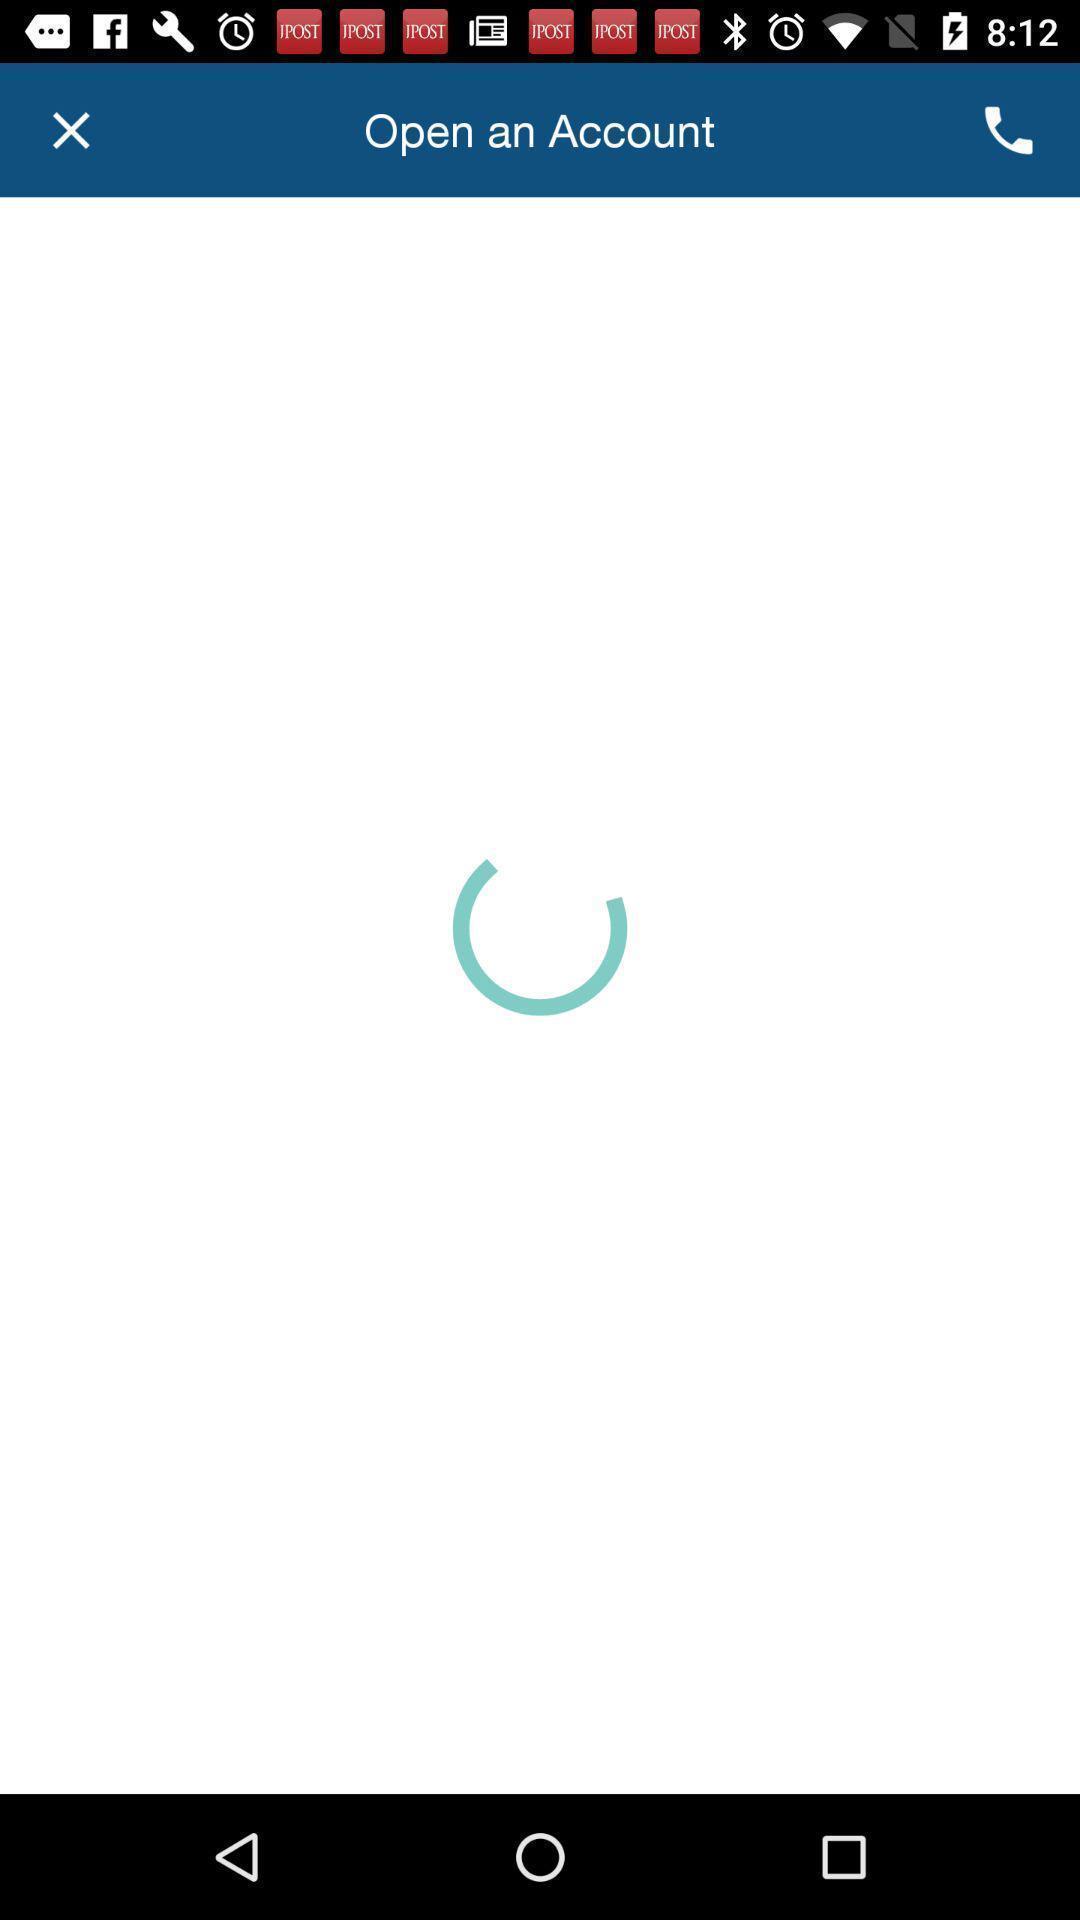Provide a description of this screenshot. Screen displaying the loading page to open an account. 